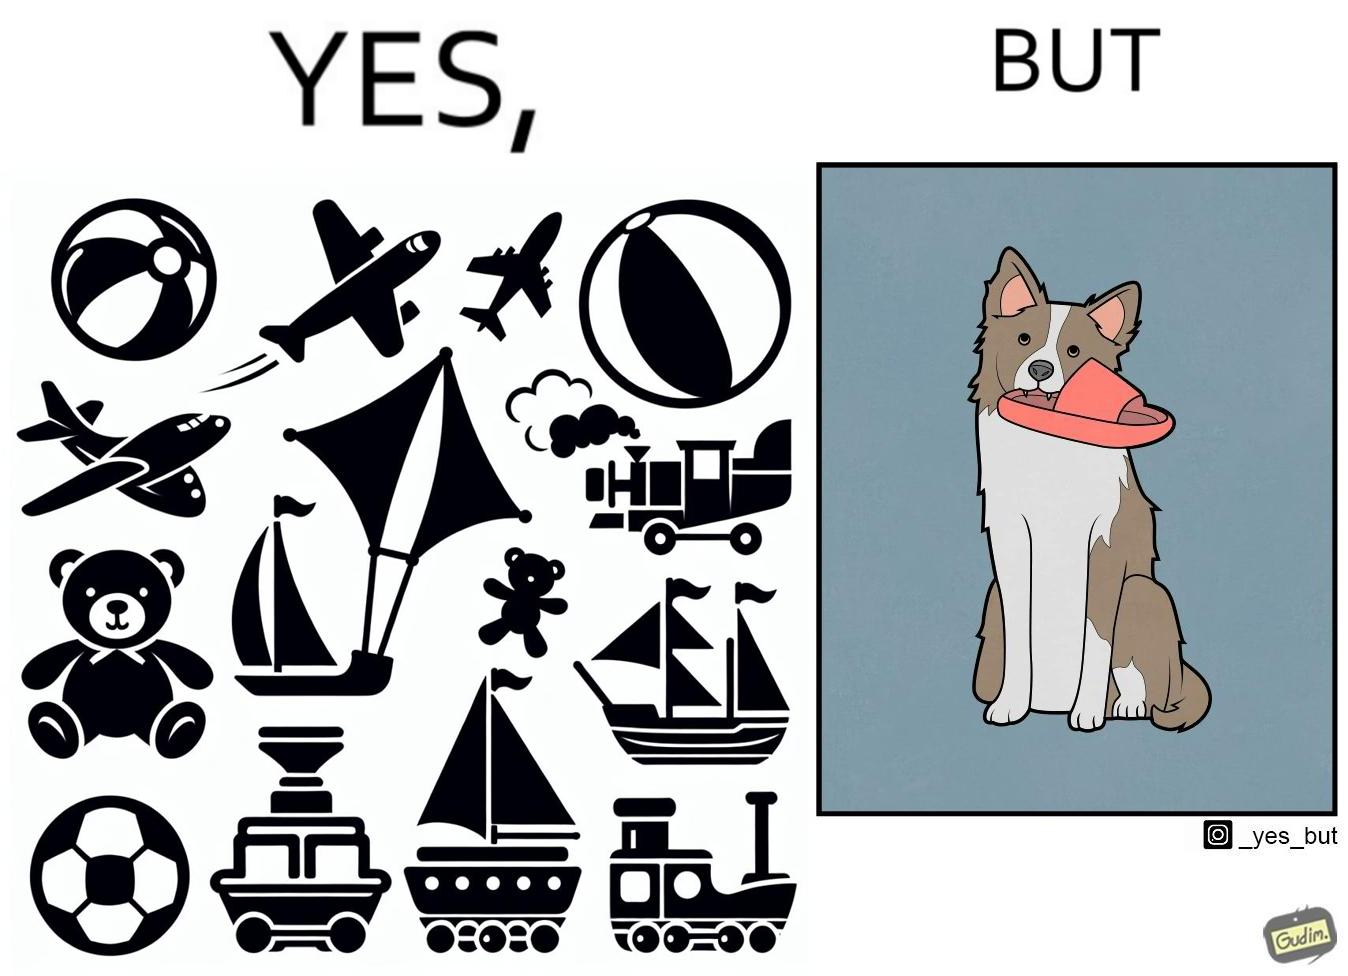Describe what you see in the left and right parts of this image. In the left part of the image: a bunch of toys. In the right part of the image: a dog holding a slipper in its mouth. 